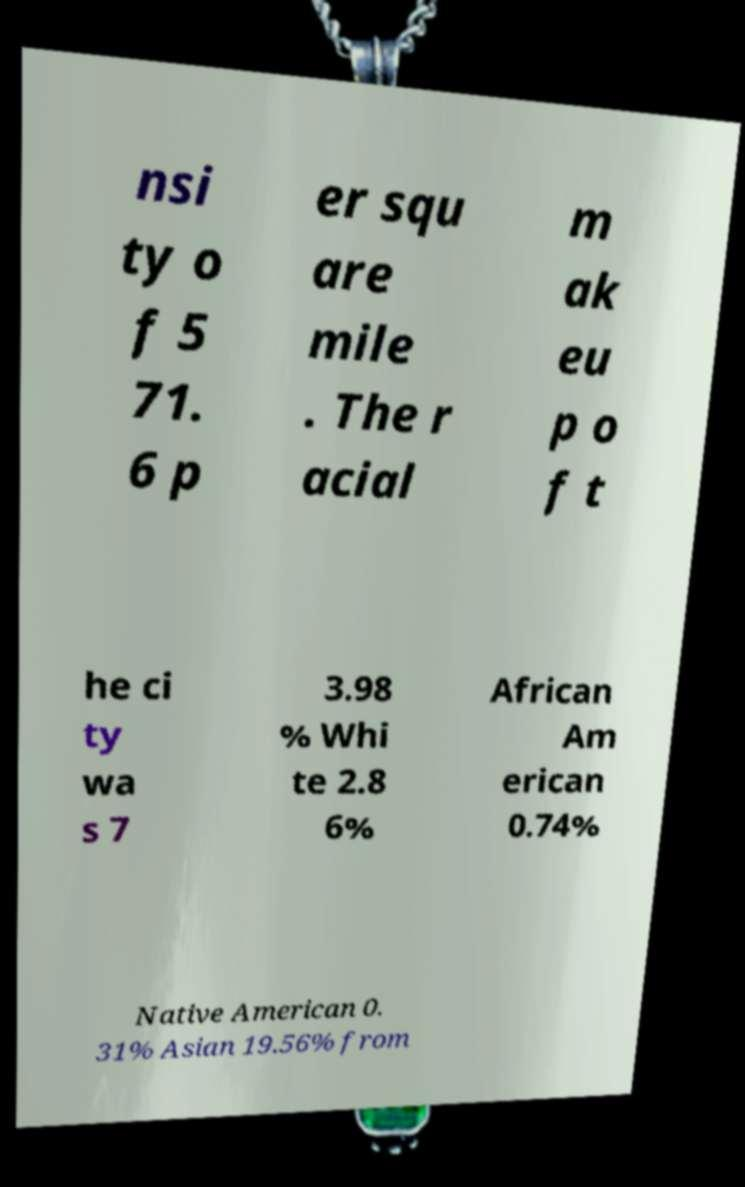Can you accurately transcribe the text from the provided image for me? nsi ty o f 5 71. 6 p er squ are mile . The r acial m ak eu p o f t he ci ty wa s 7 3.98 % Whi te 2.8 6% African Am erican 0.74% Native American 0. 31% Asian 19.56% from 